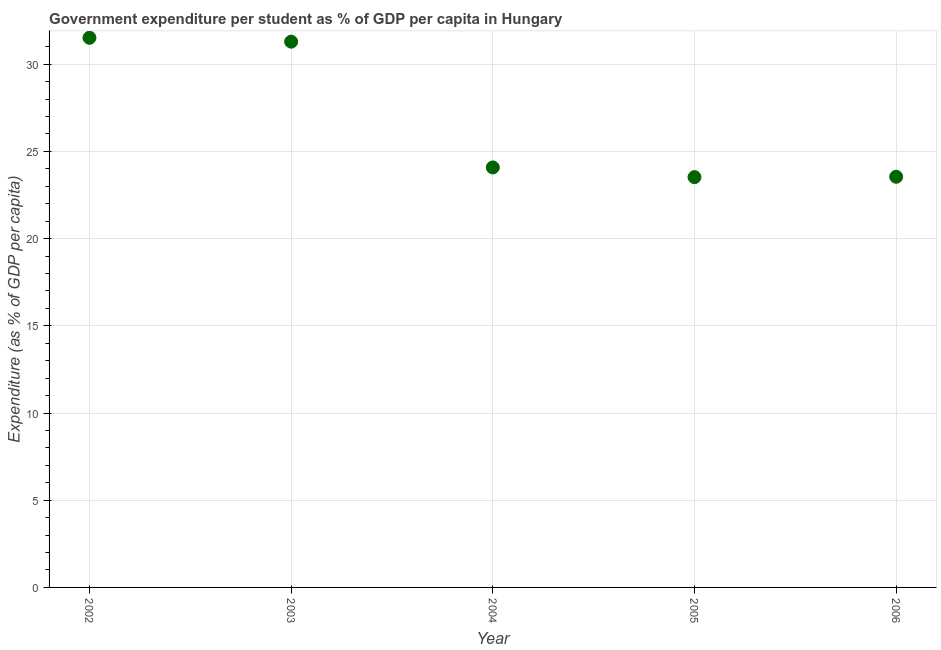What is the government expenditure per student in 2003?
Offer a very short reply. 31.29. Across all years, what is the maximum government expenditure per student?
Your answer should be compact. 31.51. Across all years, what is the minimum government expenditure per student?
Keep it short and to the point. 23.53. What is the sum of the government expenditure per student?
Offer a very short reply. 133.96. What is the difference between the government expenditure per student in 2002 and 2003?
Your answer should be compact. 0.22. What is the average government expenditure per student per year?
Provide a succinct answer. 26.79. What is the median government expenditure per student?
Your answer should be very brief. 24.08. Do a majority of the years between 2002 and 2004 (inclusive) have government expenditure per student greater than 5 %?
Your answer should be compact. Yes. What is the ratio of the government expenditure per student in 2002 to that in 2006?
Offer a very short reply. 1.34. Is the government expenditure per student in 2003 less than that in 2006?
Offer a very short reply. No. Is the difference between the government expenditure per student in 2003 and 2004 greater than the difference between any two years?
Keep it short and to the point. No. What is the difference between the highest and the second highest government expenditure per student?
Offer a very short reply. 0.22. Is the sum of the government expenditure per student in 2002 and 2004 greater than the maximum government expenditure per student across all years?
Your answer should be very brief. Yes. What is the difference between the highest and the lowest government expenditure per student?
Offer a very short reply. 7.99. Does the government expenditure per student monotonically increase over the years?
Offer a very short reply. No. What is the difference between two consecutive major ticks on the Y-axis?
Your answer should be very brief. 5. Does the graph contain grids?
Ensure brevity in your answer.  Yes. What is the title of the graph?
Give a very brief answer. Government expenditure per student as % of GDP per capita in Hungary. What is the label or title of the X-axis?
Your answer should be very brief. Year. What is the label or title of the Y-axis?
Your answer should be compact. Expenditure (as % of GDP per capita). What is the Expenditure (as % of GDP per capita) in 2002?
Your answer should be very brief. 31.51. What is the Expenditure (as % of GDP per capita) in 2003?
Make the answer very short. 31.29. What is the Expenditure (as % of GDP per capita) in 2004?
Your answer should be compact. 24.08. What is the Expenditure (as % of GDP per capita) in 2005?
Make the answer very short. 23.53. What is the Expenditure (as % of GDP per capita) in 2006?
Provide a short and direct response. 23.55. What is the difference between the Expenditure (as % of GDP per capita) in 2002 and 2003?
Keep it short and to the point. 0.22. What is the difference between the Expenditure (as % of GDP per capita) in 2002 and 2004?
Make the answer very short. 7.43. What is the difference between the Expenditure (as % of GDP per capita) in 2002 and 2005?
Provide a succinct answer. 7.99. What is the difference between the Expenditure (as % of GDP per capita) in 2002 and 2006?
Your answer should be very brief. 7.97. What is the difference between the Expenditure (as % of GDP per capita) in 2003 and 2004?
Offer a very short reply. 7.21. What is the difference between the Expenditure (as % of GDP per capita) in 2003 and 2005?
Provide a succinct answer. 7.77. What is the difference between the Expenditure (as % of GDP per capita) in 2003 and 2006?
Provide a succinct answer. 7.75. What is the difference between the Expenditure (as % of GDP per capita) in 2004 and 2005?
Offer a terse response. 0.56. What is the difference between the Expenditure (as % of GDP per capita) in 2004 and 2006?
Offer a very short reply. 0.54. What is the difference between the Expenditure (as % of GDP per capita) in 2005 and 2006?
Ensure brevity in your answer.  -0.02. What is the ratio of the Expenditure (as % of GDP per capita) in 2002 to that in 2003?
Make the answer very short. 1.01. What is the ratio of the Expenditure (as % of GDP per capita) in 2002 to that in 2004?
Ensure brevity in your answer.  1.31. What is the ratio of the Expenditure (as % of GDP per capita) in 2002 to that in 2005?
Your answer should be compact. 1.34. What is the ratio of the Expenditure (as % of GDP per capita) in 2002 to that in 2006?
Offer a very short reply. 1.34. What is the ratio of the Expenditure (as % of GDP per capita) in 2003 to that in 2005?
Your response must be concise. 1.33. What is the ratio of the Expenditure (as % of GDP per capita) in 2003 to that in 2006?
Offer a terse response. 1.33. What is the ratio of the Expenditure (as % of GDP per capita) in 2004 to that in 2005?
Your response must be concise. 1.02. What is the ratio of the Expenditure (as % of GDP per capita) in 2004 to that in 2006?
Your answer should be very brief. 1.02. 